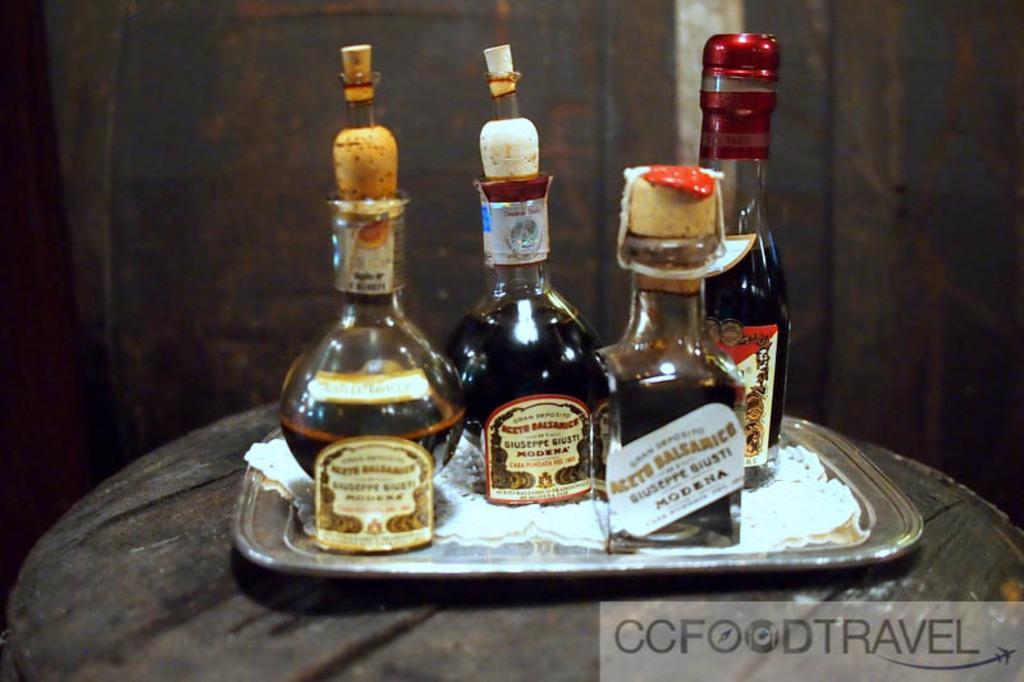Could you give a brief overview of what you see in this image? This is a table with a steel tray and four bottles on the tray. These are the cock pits which are used to seal the bottles. 